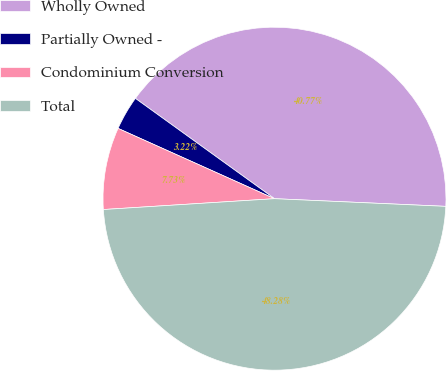<chart> <loc_0><loc_0><loc_500><loc_500><pie_chart><fcel>Wholly Owned<fcel>Partially Owned -<fcel>Condominium Conversion<fcel>Total<nl><fcel>40.77%<fcel>3.22%<fcel>7.73%<fcel>48.28%<nl></chart> 